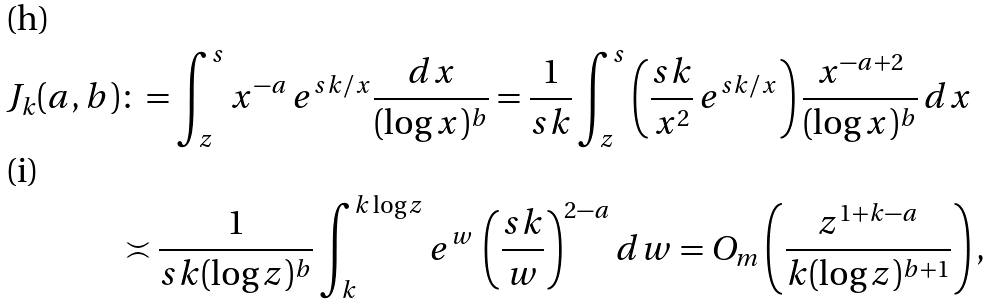<formula> <loc_0><loc_0><loc_500><loc_500>J _ { k } ( a , b ) & \colon = \int _ { z } ^ { s } x ^ { - a } \, e ^ { s k / x } \frac { d x } { ( \log x ) ^ { b } } = \frac { 1 } { s k } \int _ { z } ^ { s } \left ( \frac { s k } { x ^ { 2 } } \, e ^ { s k / x } \right ) \frac { x ^ { - a + 2 } } { ( \log x ) ^ { b } } \, d x \\ & \asymp \frac { 1 } { s k ( \log z ) ^ { b } } \int _ { k } ^ { k \log z } e ^ { w } \, \left ( \frac { s k } { w } \right ) ^ { 2 - a } d w = O _ { m } \left ( \frac { z ^ { 1 + k - a } } { k ( \log z ) ^ { b + 1 } } \right ) ,</formula> 